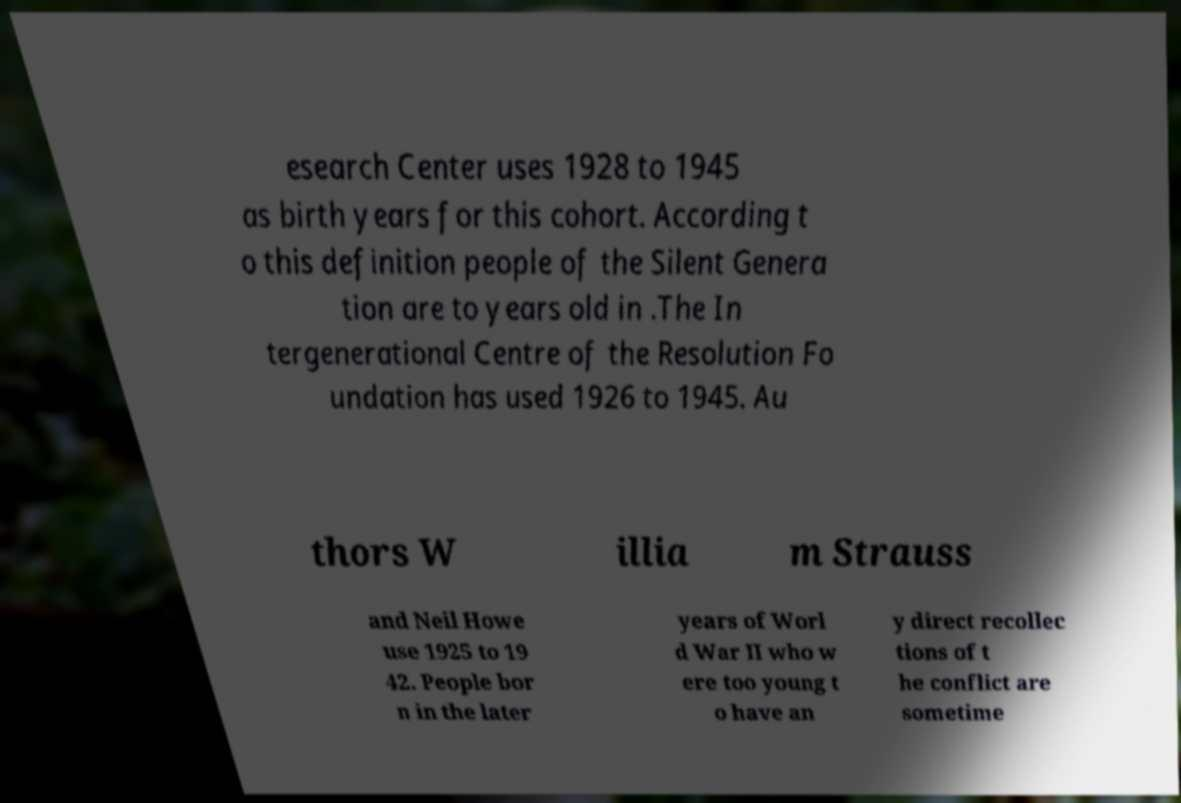Can you accurately transcribe the text from the provided image for me? esearch Center uses 1928 to 1945 as birth years for this cohort. According t o this definition people of the Silent Genera tion are to years old in .The In tergenerational Centre of the Resolution Fo undation has used 1926 to 1945. Au thors W illia m Strauss and Neil Howe use 1925 to 19 42. People bor n in the later years of Worl d War II who w ere too young t o have an y direct recollec tions of t he conflict are sometime 